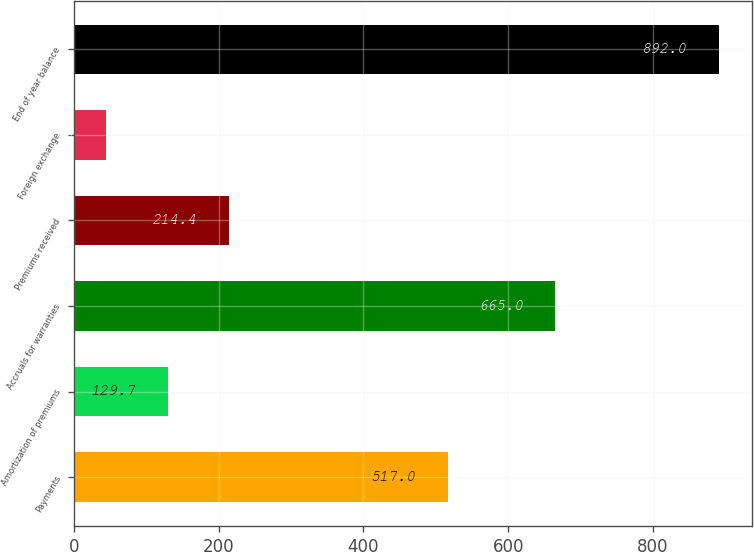<chart> <loc_0><loc_0><loc_500><loc_500><bar_chart><fcel>Payments<fcel>Amortization of premiums<fcel>Accruals for warranties<fcel>Premiums received<fcel>Foreign exchange<fcel>End of year balance<nl><fcel>517<fcel>129.7<fcel>665<fcel>214.4<fcel>45<fcel>892<nl></chart> 